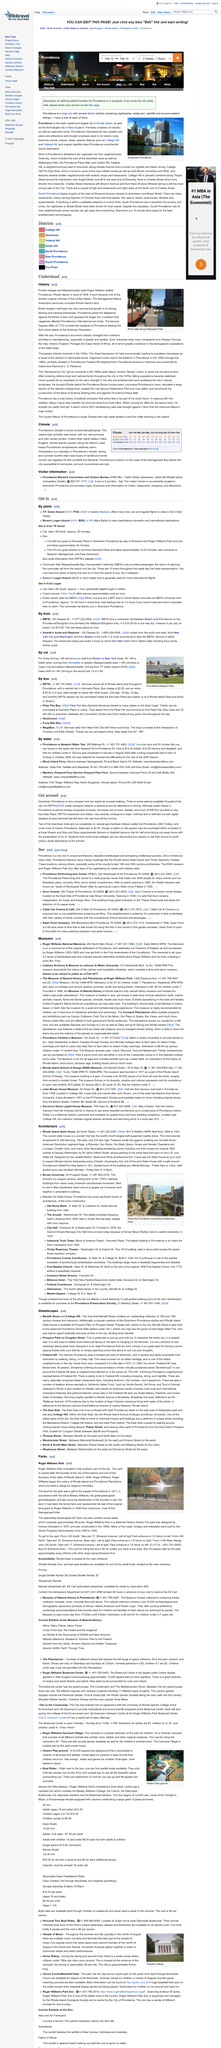Give some essential details in this illustration. Providence strongly opposed the Sugar Act, which was a taxation act that was implemented by the British government in 1764. Roger Williams settled Providence in June of 1636. The image was taken at the River Walk along Waterplace Park. 